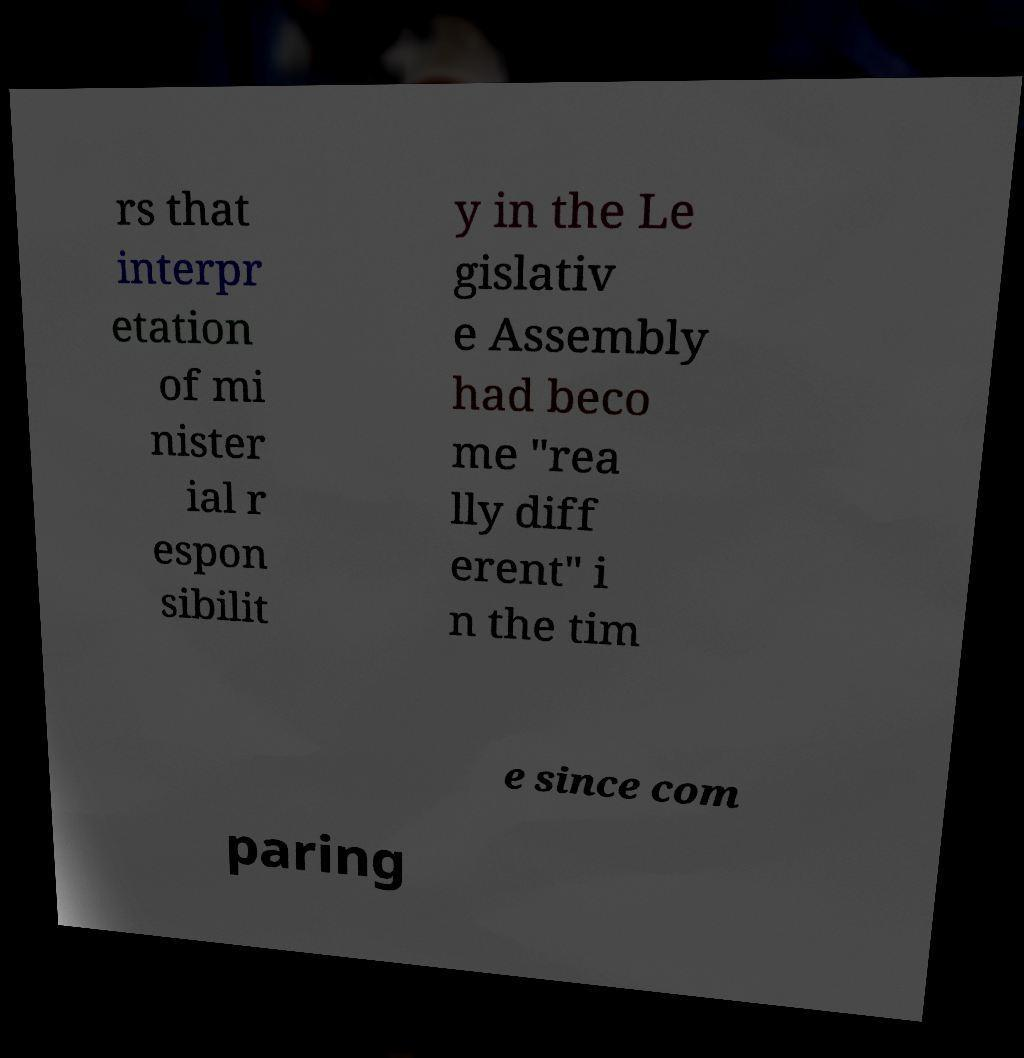What messages or text are displayed in this image? I need them in a readable, typed format. rs that interpr etation of mi nister ial r espon sibilit y in the Le gislativ e Assembly had beco me "rea lly diff erent" i n the tim e since com paring 